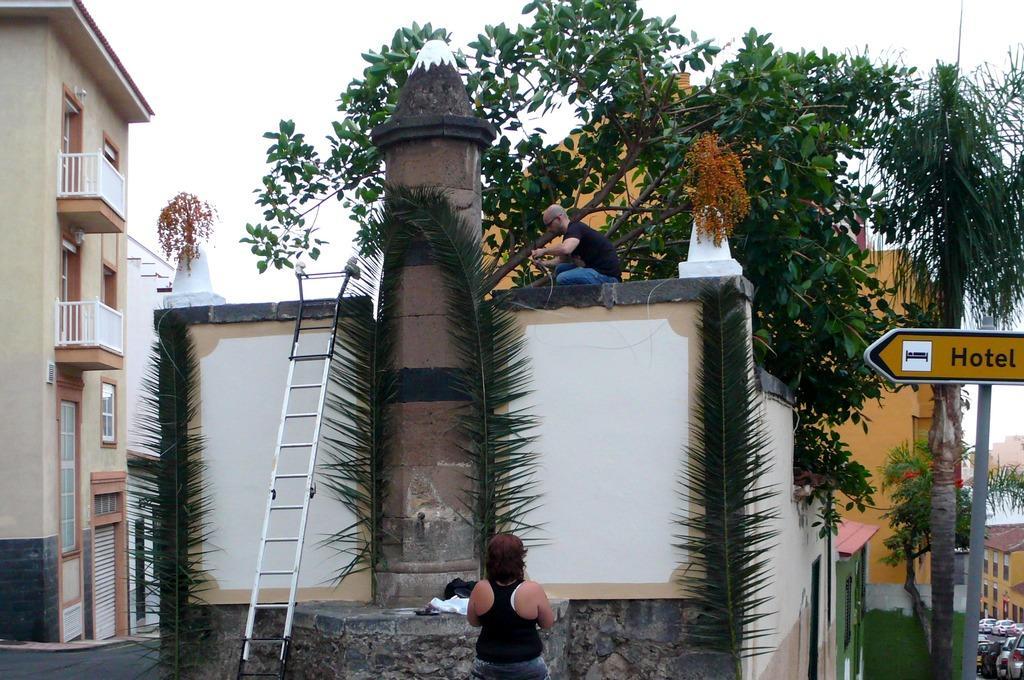Could you give a brief overview of what you see in this image? In this picture we can see few people, a man is seated on the wall, beside to the wall we can find a ladder and a sign board, in the background we can find few trees, buildings and vehicles. 